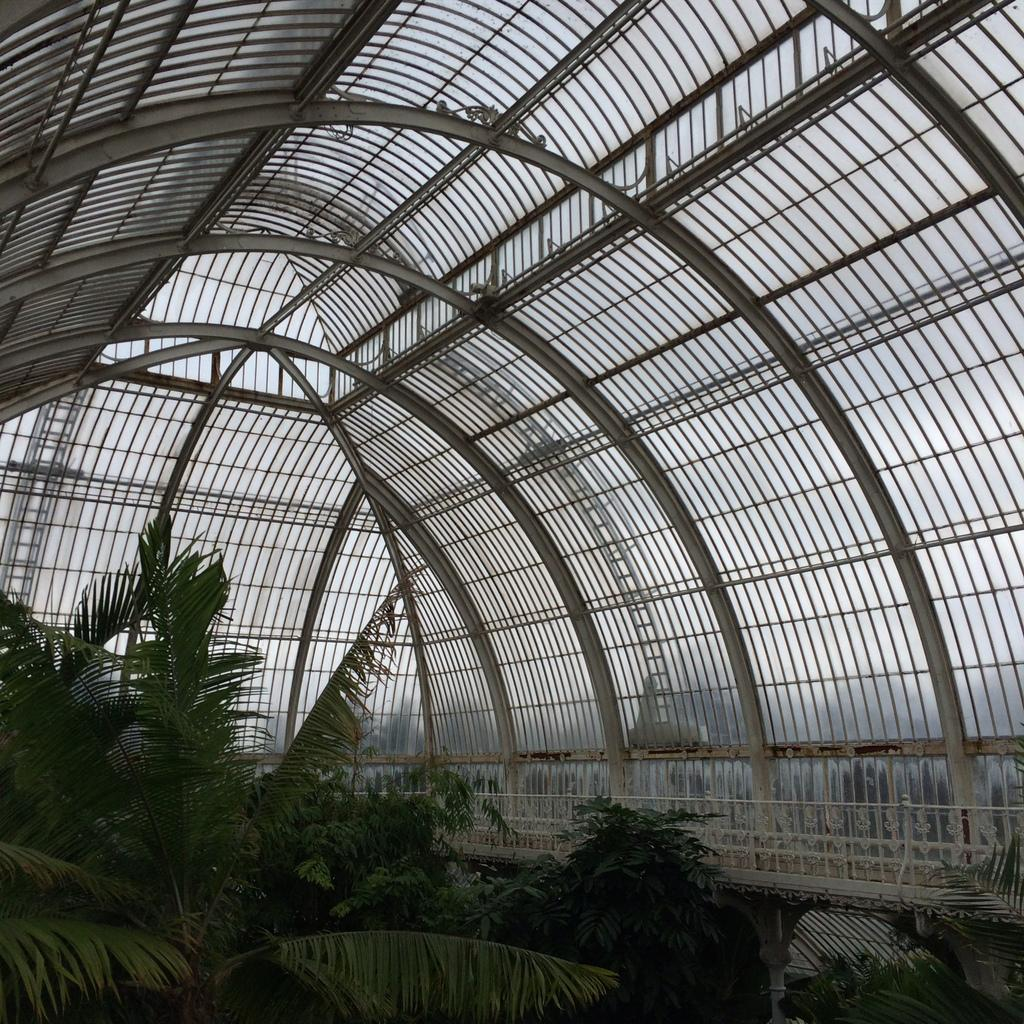What type of vegetation is present in the image? There are trees in the image. What material is the fencing made of in the image? The fencing in the image is made of metal. What type of structure can be seen in the image? There is a shed in the image. Where is the box located in the image? There is no box present in the image. Can you see any deer in the image? There are no deer present in the image. 